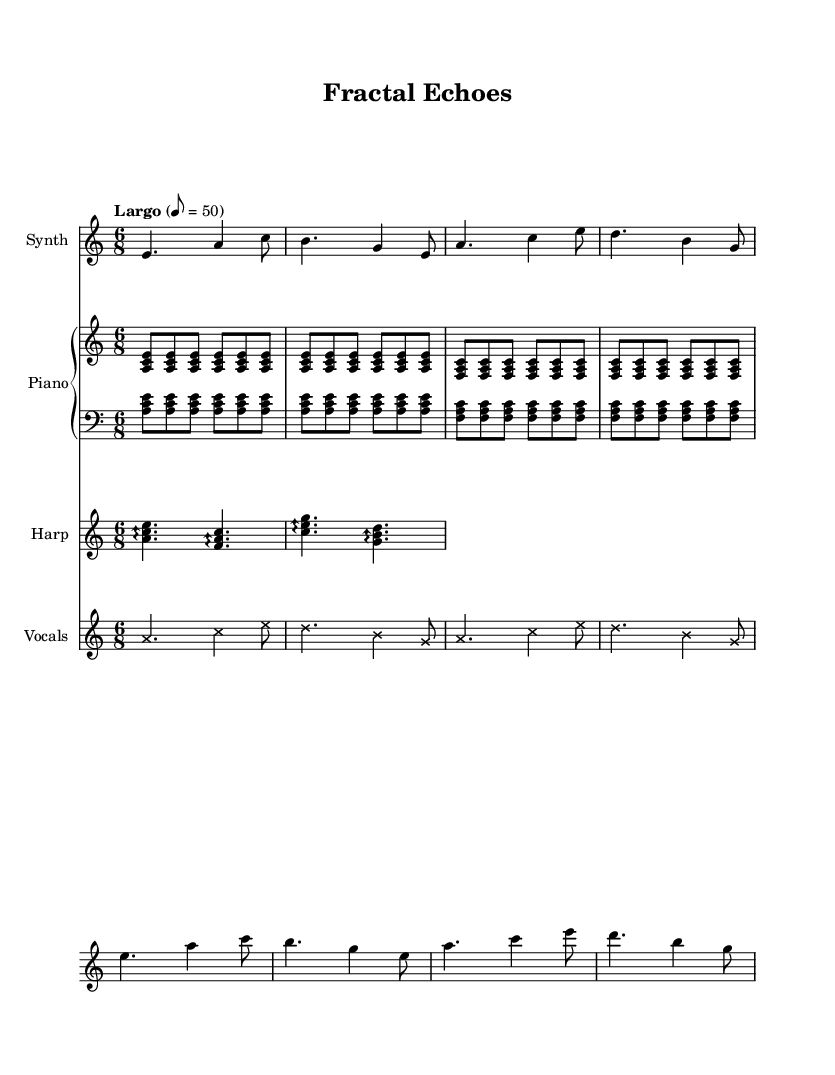What is the key signature of this music? The key signature is A minor, which has no sharps or flats.
Answer: A minor What is the time signature of the piece? The time signature is indicated as 6/8, which means there are six eighth notes in each measure.
Answer: 6/8 What is the tempo marking for the score? The tempo marking states "Largo" with a tempo of 50 beats per minute, indicating a slow and broad tempo.
Answer: Largo, 8 = 50 How many instruments are present in the score? There are four instruments indicated: Synth, Piano, Harp, and Vocals, as shown in the score headers.
Answer: Four Which section of the music uses arpeggios? The arpeggio usage is seen in the Harp part, where the notes are played in an arpeggiated manner indicated by the arrow notation.
Answer: Harp What is the pattern used in the piano section? The piano section uses repeating triads built on the notes A, C, E and F, A, C, creating a pattern of ascension through arpeggiated chords.
Answer: Repeating triads What is the rhythmic feel created by the 6/8 time signature? The 6/8 time signature creates a compound meter feel, often resulting in a flowing or lilting rhythm suitable for ethereal soundscapes.
Answer: Flowing 